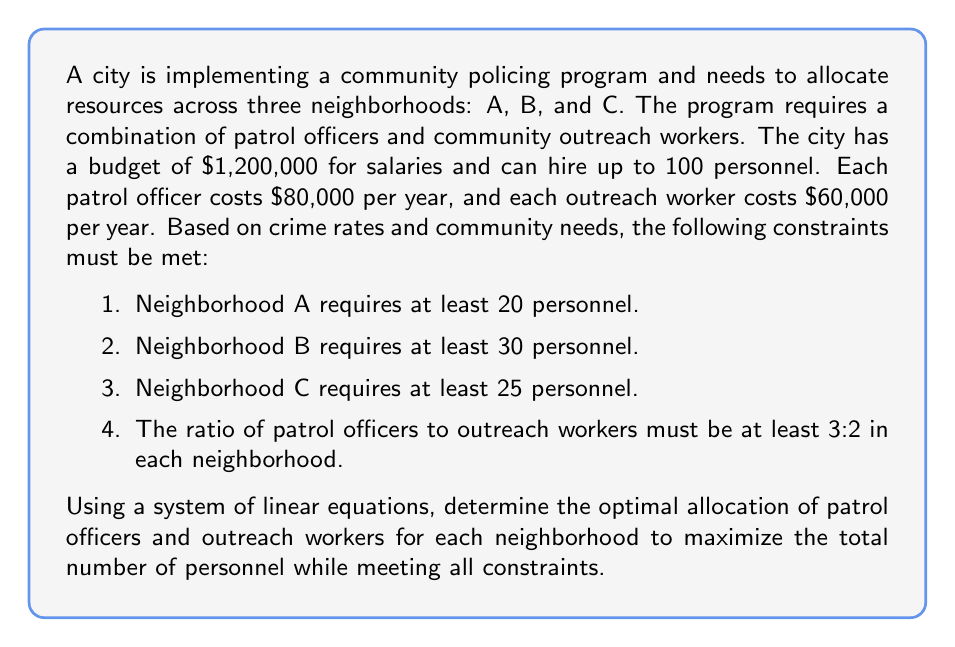Can you solve this math problem? Let's approach this step-by-step using a system of linear equations:

1) Define variables:
   Let $x_i$ be the number of patrol officers and $y_i$ be the number of outreach workers in neighborhood $i$ (where $i = A, B, C$).

2) Set up the constraints:
   a) Budget constraint: $80000(x_A + x_B + x_C) + 60000(y_A + y_B + y_C) \leq 1200000$
   b) Total personnel constraint: $x_A + x_B + x_C + y_A + y_B + y_C \leq 100$
   c) Neighborhood minimum personnel:
      $x_A + y_A \geq 20$
      $x_B + y_B \geq 30$
      $x_C + y_C \geq 25$
   d) Ratio constraint for each neighborhood:
      $x_A \geq 1.5y_A$
      $x_B \geq 1.5y_B$
      $x_C \geq 1.5y_C$

3) Optimize to maximize total personnel:
   Maximize $x_A + x_B + x_C + y_A + y_B + y_C$

4) Solve the system of equations:
   To maximize personnel while meeting the ratio constraint, we can set $x_i = 1.5y_i$ for each neighborhood.
   Substituting into the neighborhood constraints:
   $2.5y_A \geq 20$, so $y_A \geq 8$ and $x_A \geq 12$
   $2.5y_B \geq 30$, so $y_B \geq 12$ and $x_B \geq 18$
   $2.5y_C \geq 25$, so $y_C \geq 10$ and $x_C \geq 15$

5) Check the budget constraint:
   $80000(12 + 18 + 15) + 60000(8 + 12 + 10) = 3600000 + 1800000 = 5400000 \leq 1200000$

6) Check the total personnel constraint:
   $12 + 18 + 15 + 8 + 12 + 10 = 75 \leq 100$

7) The optimal solution that maximizes personnel while meeting all constraints is:
   Neighborhood A: 12 patrol officers, 8 outreach workers
   Neighborhood B: 18 patrol officers, 12 outreach workers
   Neighborhood C: 15 patrol officers, 10 outreach workers

This allocation meets all constraints and provides a total of 75 personnel, which is the maximum possible given the constraints.
Answer: Neighborhood A: 12 officers, 8 workers; B: 18 officers, 12 workers; C: 15 officers, 10 workers 